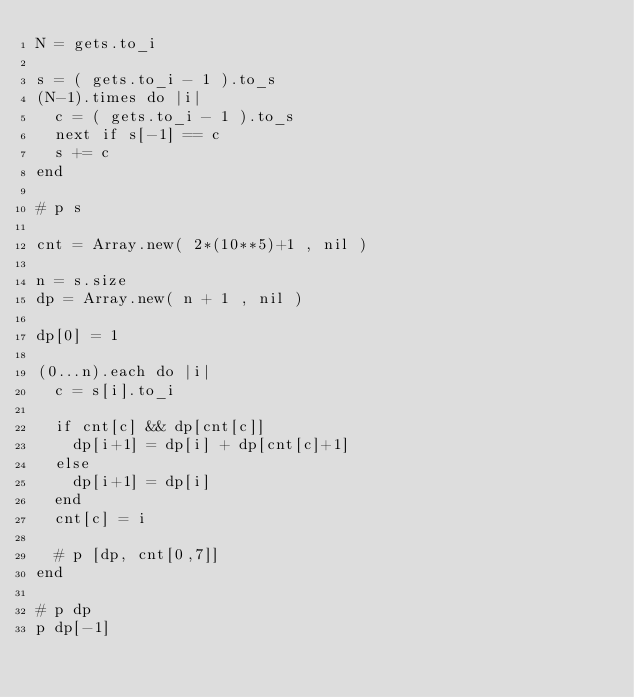Convert code to text. <code><loc_0><loc_0><loc_500><loc_500><_Ruby_>N = gets.to_i

s = ( gets.to_i - 1 ).to_s
(N-1).times do |i|
  c = ( gets.to_i - 1 ).to_s
  next if s[-1] == c
  s += c
end

# p s

cnt = Array.new( 2*(10**5)+1 , nil )

n = s.size
dp = Array.new( n + 1 , nil )

dp[0] = 1

(0...n).each do |i|
  c = s[i].to_i
  
  if cnt[c] && dp[cnt[c]]
    dp[i+1] = dp[i] + dp[cnt[c]+1]
  else
    dp[i+1] = dp[i] 
  end
  cnt[c] = i
  
  # p [dp, cnt[0,7]]
end

# p dp
p dp[-1]



</code> 